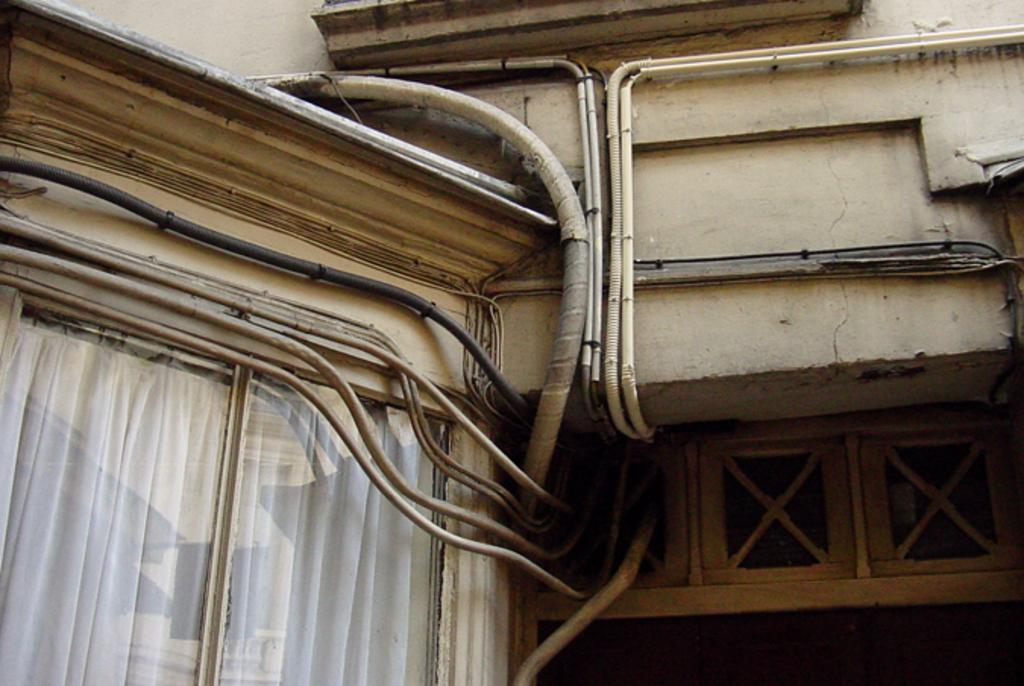What type of structure is visible in the image? There is a building in the image. What can be seen attached to the building? There are wire pipes visible in the image. Can you describe any specific features of the building? There is a white color curtain on the bottom left side of the image. What channel is the father watching on the quilt in the image? There is no father, channel, or quilt present in the image. 